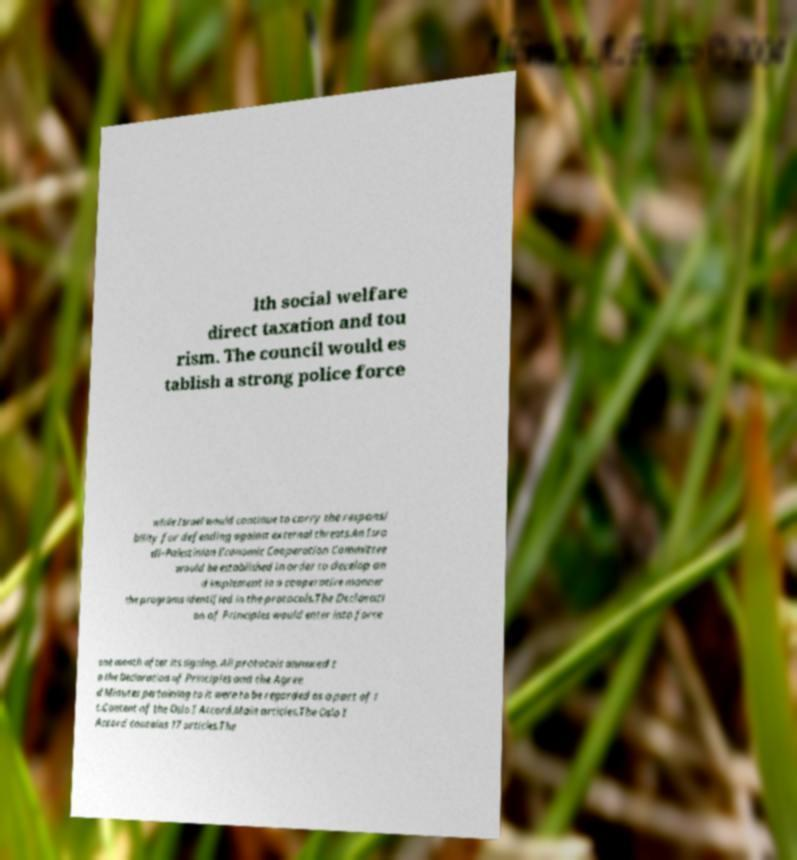I need the written content from this picture converted into text. Can you do that? lth social welfare direct taxation and tou rism. The council would es tablish a strong police force while Israel would continue to carry the responsi bility for defending against external threats.An Isra eli–Palestinian Economic Cooperation Committee would be established in order to develop an d implement in a cooperative manner the programs identified in the protocols.The Declarati on of Principles would enter into force one month after its signing. All protocols annexed t o the Declaration of Principles and the Agree d Minutes pertaining to it were to be regarded as a part of i t.Content of the Oslo I Accord.Main articles.The Oslo I Accord contains 17 articles.The 